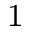<formula> <loc_0><loc_0><loc_500><loc_500>^ { 1 }</formula> 